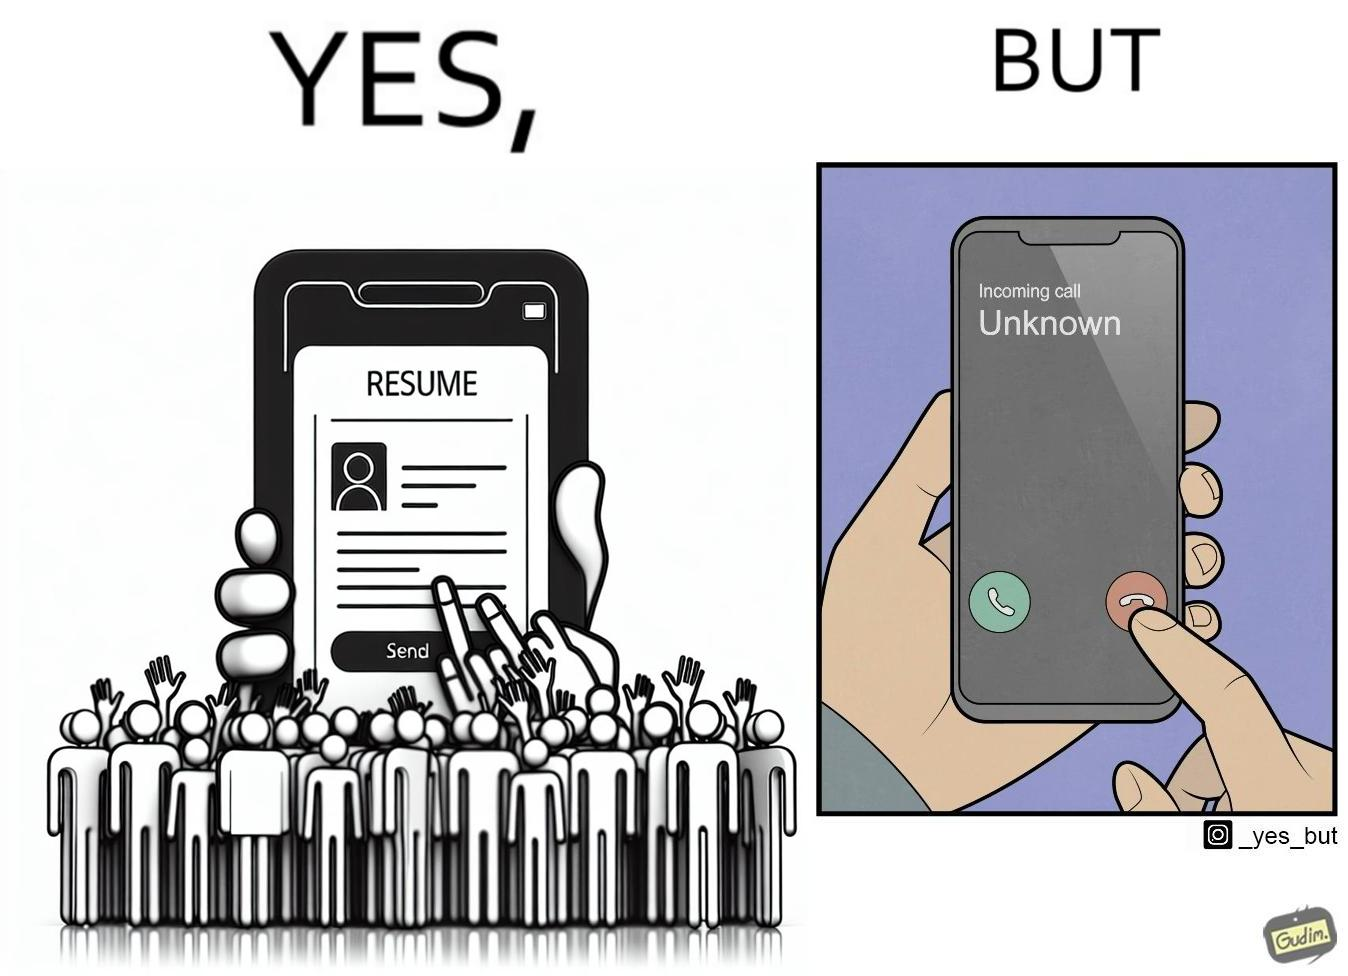Does this image contain satire or humor? Yes, this image is satirical. 